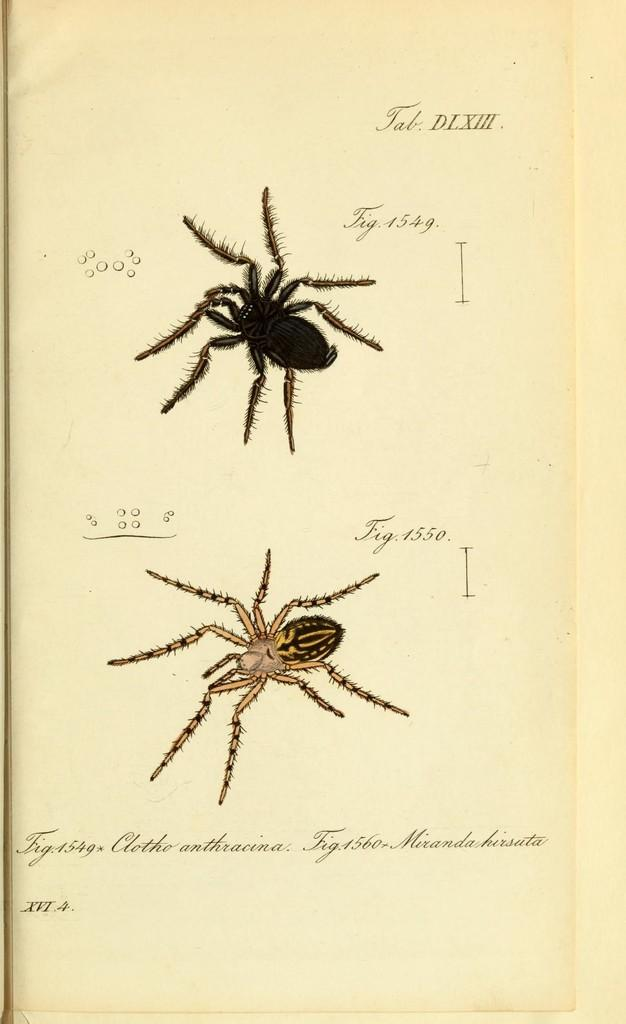What is present on the paper in the image? The paper has a picture of spiders. What else can be found on the paper besides the picture? There is writing on the paper. What is the chance of the paper catching fire in the image? There is no indication of fire or any risk of fire in the image, so it's not possible to determine the chance of the paper catching fire. 